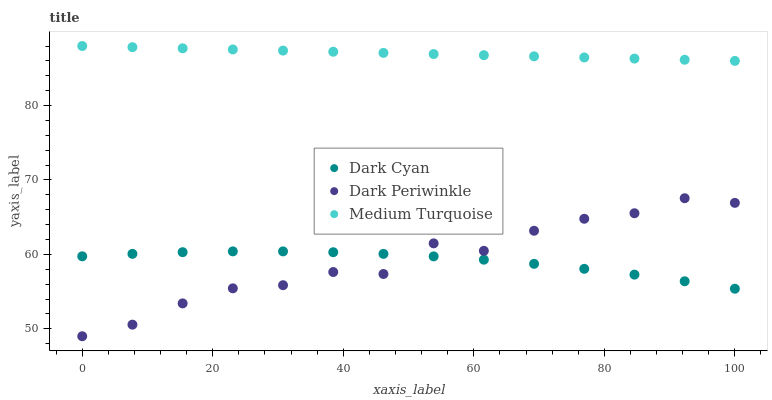Does Dark Cyan have the minimum area under the curve?
Answer yes or no. Yes. Does Medium Turquoise have the maximum area under the curve?
Answer yes or no. Yes. Does Dark Periwinkle have the minimum area under the curve?
Answer yes or no. No. Does Dark Periwinkle have the maximum area under the curve?
Answer yes or no. No. Is Medium Turquoise the smoothest?
Answer yes or no. Yes. Is Dark Periwinkle the roughest?
Answer yes or no. Yes. Is Dark Periwinkle the smoothest?
Answer yes or no. No. Is Medium Turquoise the roughest?
Answer yes or no. No. Does Dark Periwinkle have the lowest value?
Answer yes or no. Yes. Does Medium Turquoise have the lowest value?
Answer yes or no. No. Does Medium Turquoise have the highest value?
Answer yes or no. Yes. Does Dark Periwinkle have the highest value?
Answer yes or no. No. Is Dark Periwinkle less than Medium Turquoise?
Answer yes or no. Yes. Is Medium Turquoise greater than Dark Cyan?
Answer yes or no. Yes. Does Dark Cyan intersect Dark Periwinkle?
Answer yes or no. Yes. Is Dark Cyan less than Dark Periwinkle?
Answer yes or no. No. Is Dark Cyan greater than Dark Periwinkle?
Answer yes or no. No. Does Dark Periwinkle intersect Medium Turquoise?
Answer yes or no. No. 